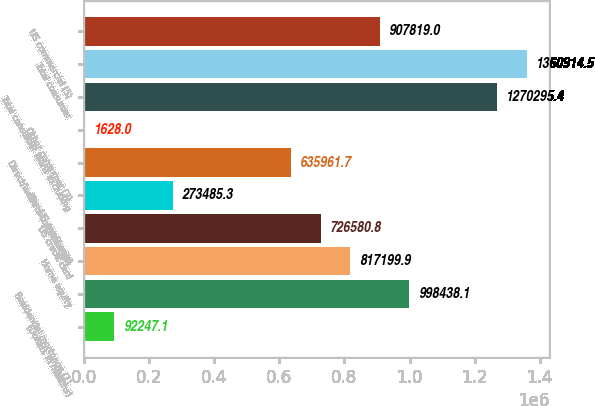<chart> <loc_0><loc_0><loc_500><loc_500><bar_chart><fcel>(Dollars in millions)<fcel>Residential mortgage (1)<fcel>Home equity<fcel>US credit card<fcel>Non-US credit card<fcel>Direct/Indirect consumer (2)<fcel>Other consumer (3)<fcel>Total consumer loans excluding<fcel>Total consumer<fcel>US commercial (5)<nl><fcel>92247.1<fcel>998438<fcel>817200<fcel>726581<fcel>273485<fcel>635962<fcel>1628<fcel>1.2703e+06<fcel>1.36091e+06<fcel>907819<nl></chart> 